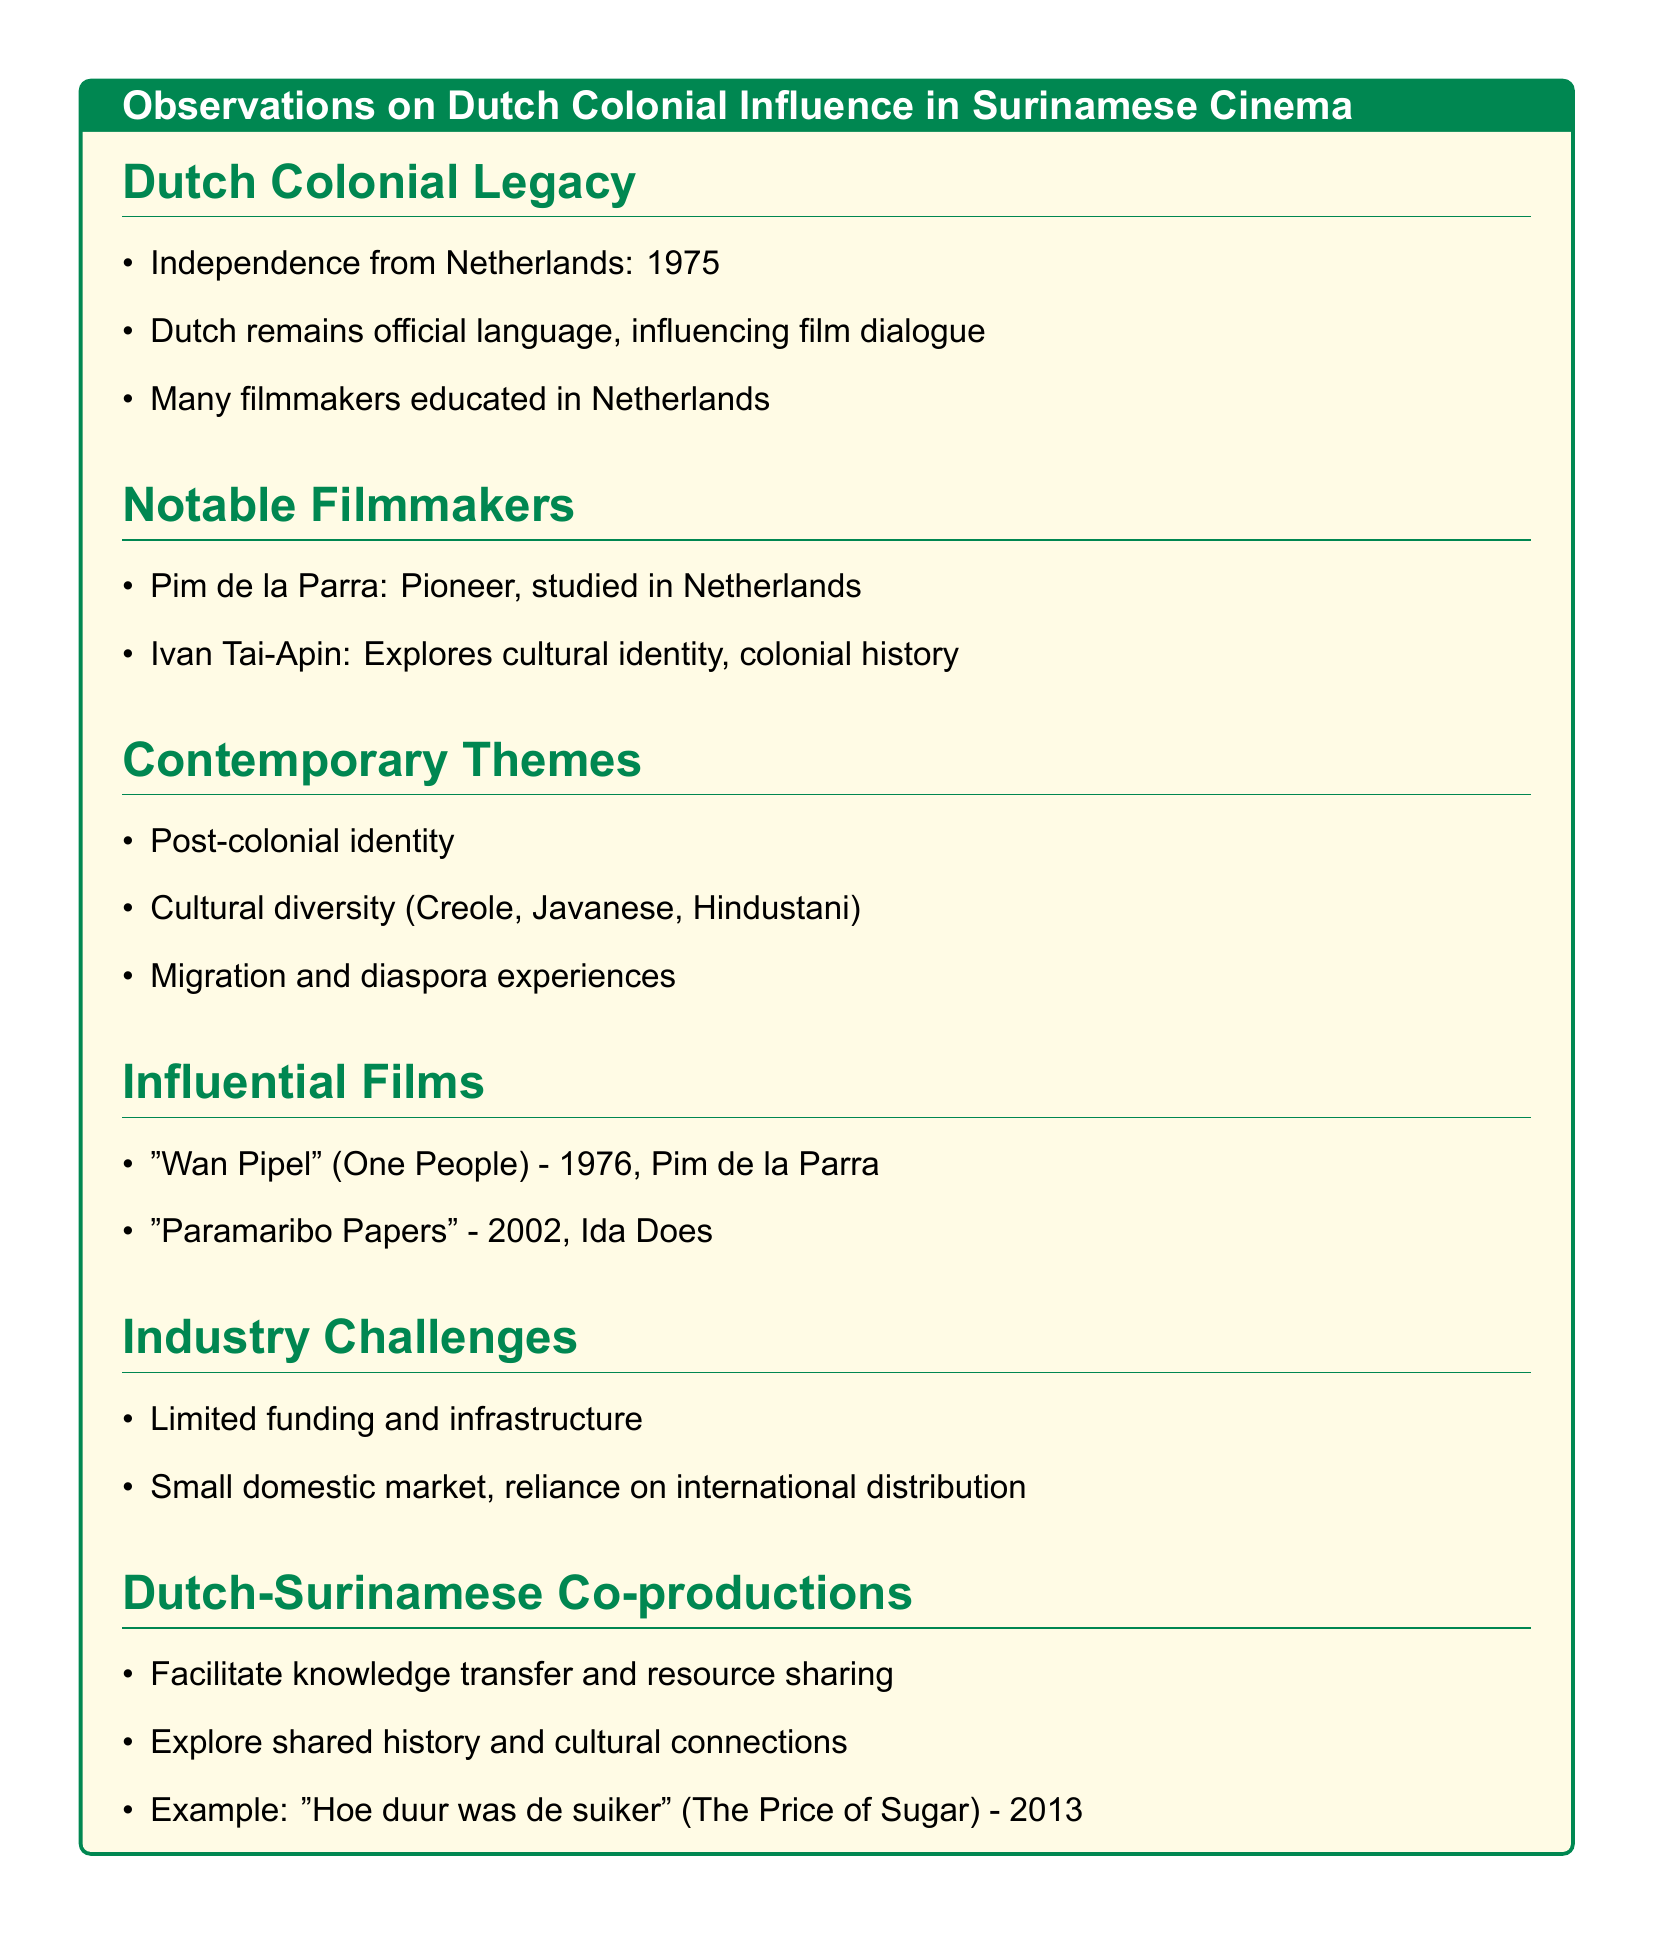What year did Suriname gain independence? The document states that Suriname gained independence from the Netherlands in 1975.
Answer: 1975 Who is a notable Surinamese filmmaker who studied in the Netherlands? Pim de la Parra is mentioned as a pioneer of Surinamese cinema who studied in the Netherlands.
Answer: Pim de la Parra What themes are recurrent in contemporary Surinamese cinema? The document lists post-colonial identity, cultural diversity, and migration among the recurring topics in contemporary cinema.
Answer: Post-colonial identity What is a key challenge faced by the Surinamese film industry? The document points out limited funding and a small domestic market as major challenges for the industry.
Answer: Limited funding Which film directed by Ida Does was mentioned as influential? "Paramaribo Papers" is highlighted as an influential film directed by Ida Does.
Answer: Paramaribo Papers What is one benefit of Dutch-Surinamese co-productions? The document notes that these co-productions facilitate knowledge transfer and resource sharing.
Answer: Knowledge transfer What is the official language of Suriname? The document mentions that Dutch remains an official language in Suriname.
Answer: Dutch Which film serves as an example of a Dutch-Surinamese co-production? The film "Hoe duur was de suiker" is provided as an example of a co-production.
Answer: Hoe duur was de suiker What cultural influences are reflected in contemporary Surinamese cinema? The document references Creole, Javanese, and Hindustani influences as part of the cultural diversity in the films.
Answer: Creole, Javanese, Hindustani 